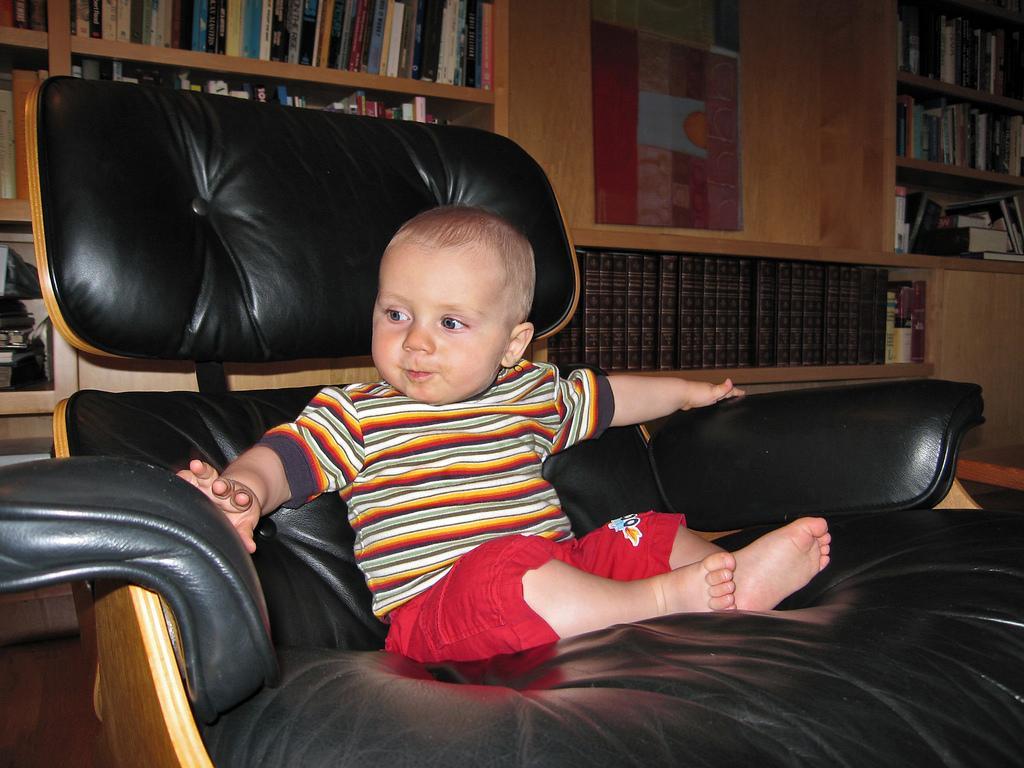How would you summarize this image in a sentence or two? In the image,there is a black sofa chair there was a baby sitting on the chair,in the background there are plenty of books in the shelf,it is a wooden shelf. 